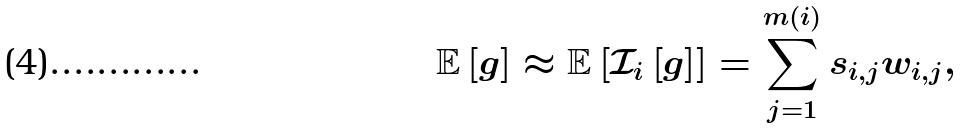Convert formula to latex. <formula><loc_0><loc_0><loc_500><loc_500>\mathbb { E } \left [ g \right ] \approx \mathbb { E } \left [ \mathcal { I } _ { i } \left [ g \right ] \right ] = \sum _ { j = 1 } ^ { m ( i ) } s _ { i , j } w _ { i , j } ,</formula> 